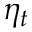Convert formula to latex. <formula><loc_0><loc_0><loc_500><loc_500>\eta _ { t }</formula> 